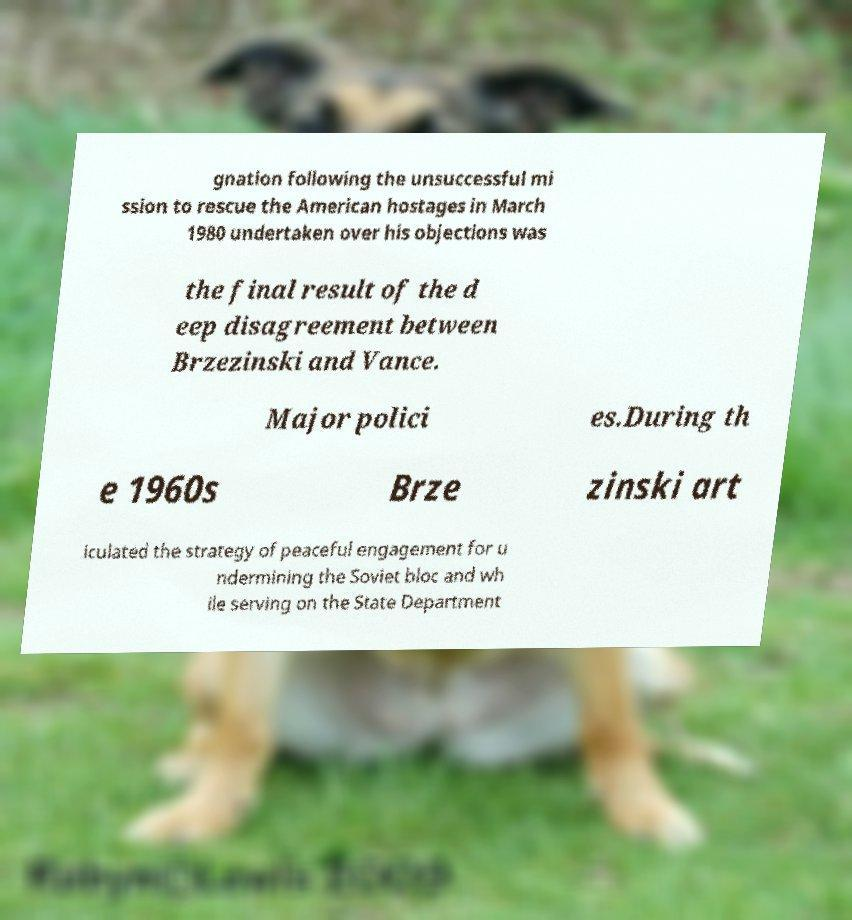Please identify and transcribe the text found in this image. gnation following the unsuccessful mi ssion to rescue the American hostages in March 1980 undertaken over his objections was the final result of the d eep disagreement between Brzezinski and Vance. Major polici es.During th e 1960s Brze zinski art iculated the strategy of peaceful engagement for u ndermining the Soviet bloc and wh ile serving on the State Department 